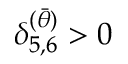Convert formula to latex. <formula><loc_0><loc_0><loc_500><loc_500>\delta _ { 5 , 6 } ^ { ( \bar { \theta } ) } > 0</formula> 